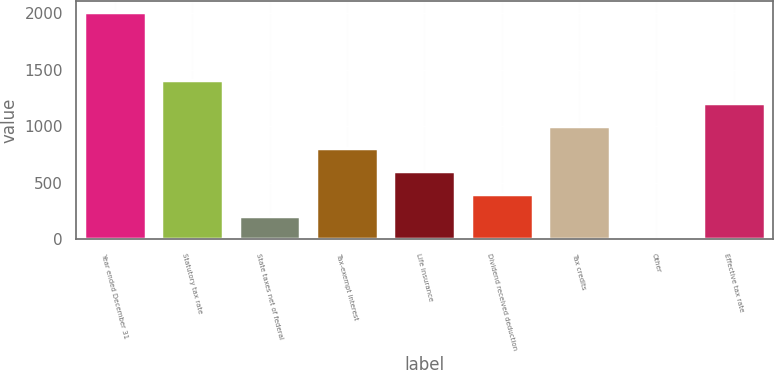Convert chart. <chart><loc_0><loc_0><loc_500><loc_500><bar_chart><fcel>Year ended December 31<fcel>Statutory tax rate<fcel>State taxes net of federal<fcel>Tax-exempt interest<fcel>Life insurance<fcel>Dividend received deduction<fcel>Tax credits<fcel>Other<fcel>Effective tax rate<nl><fcel>2012<fcel>1408.55<fcel>201.65<fcel>805.1<fcel>603.95<fcel>402.8<fcel>1006.25<fcel>0.5<fcel>1207.4<nl></chart> 